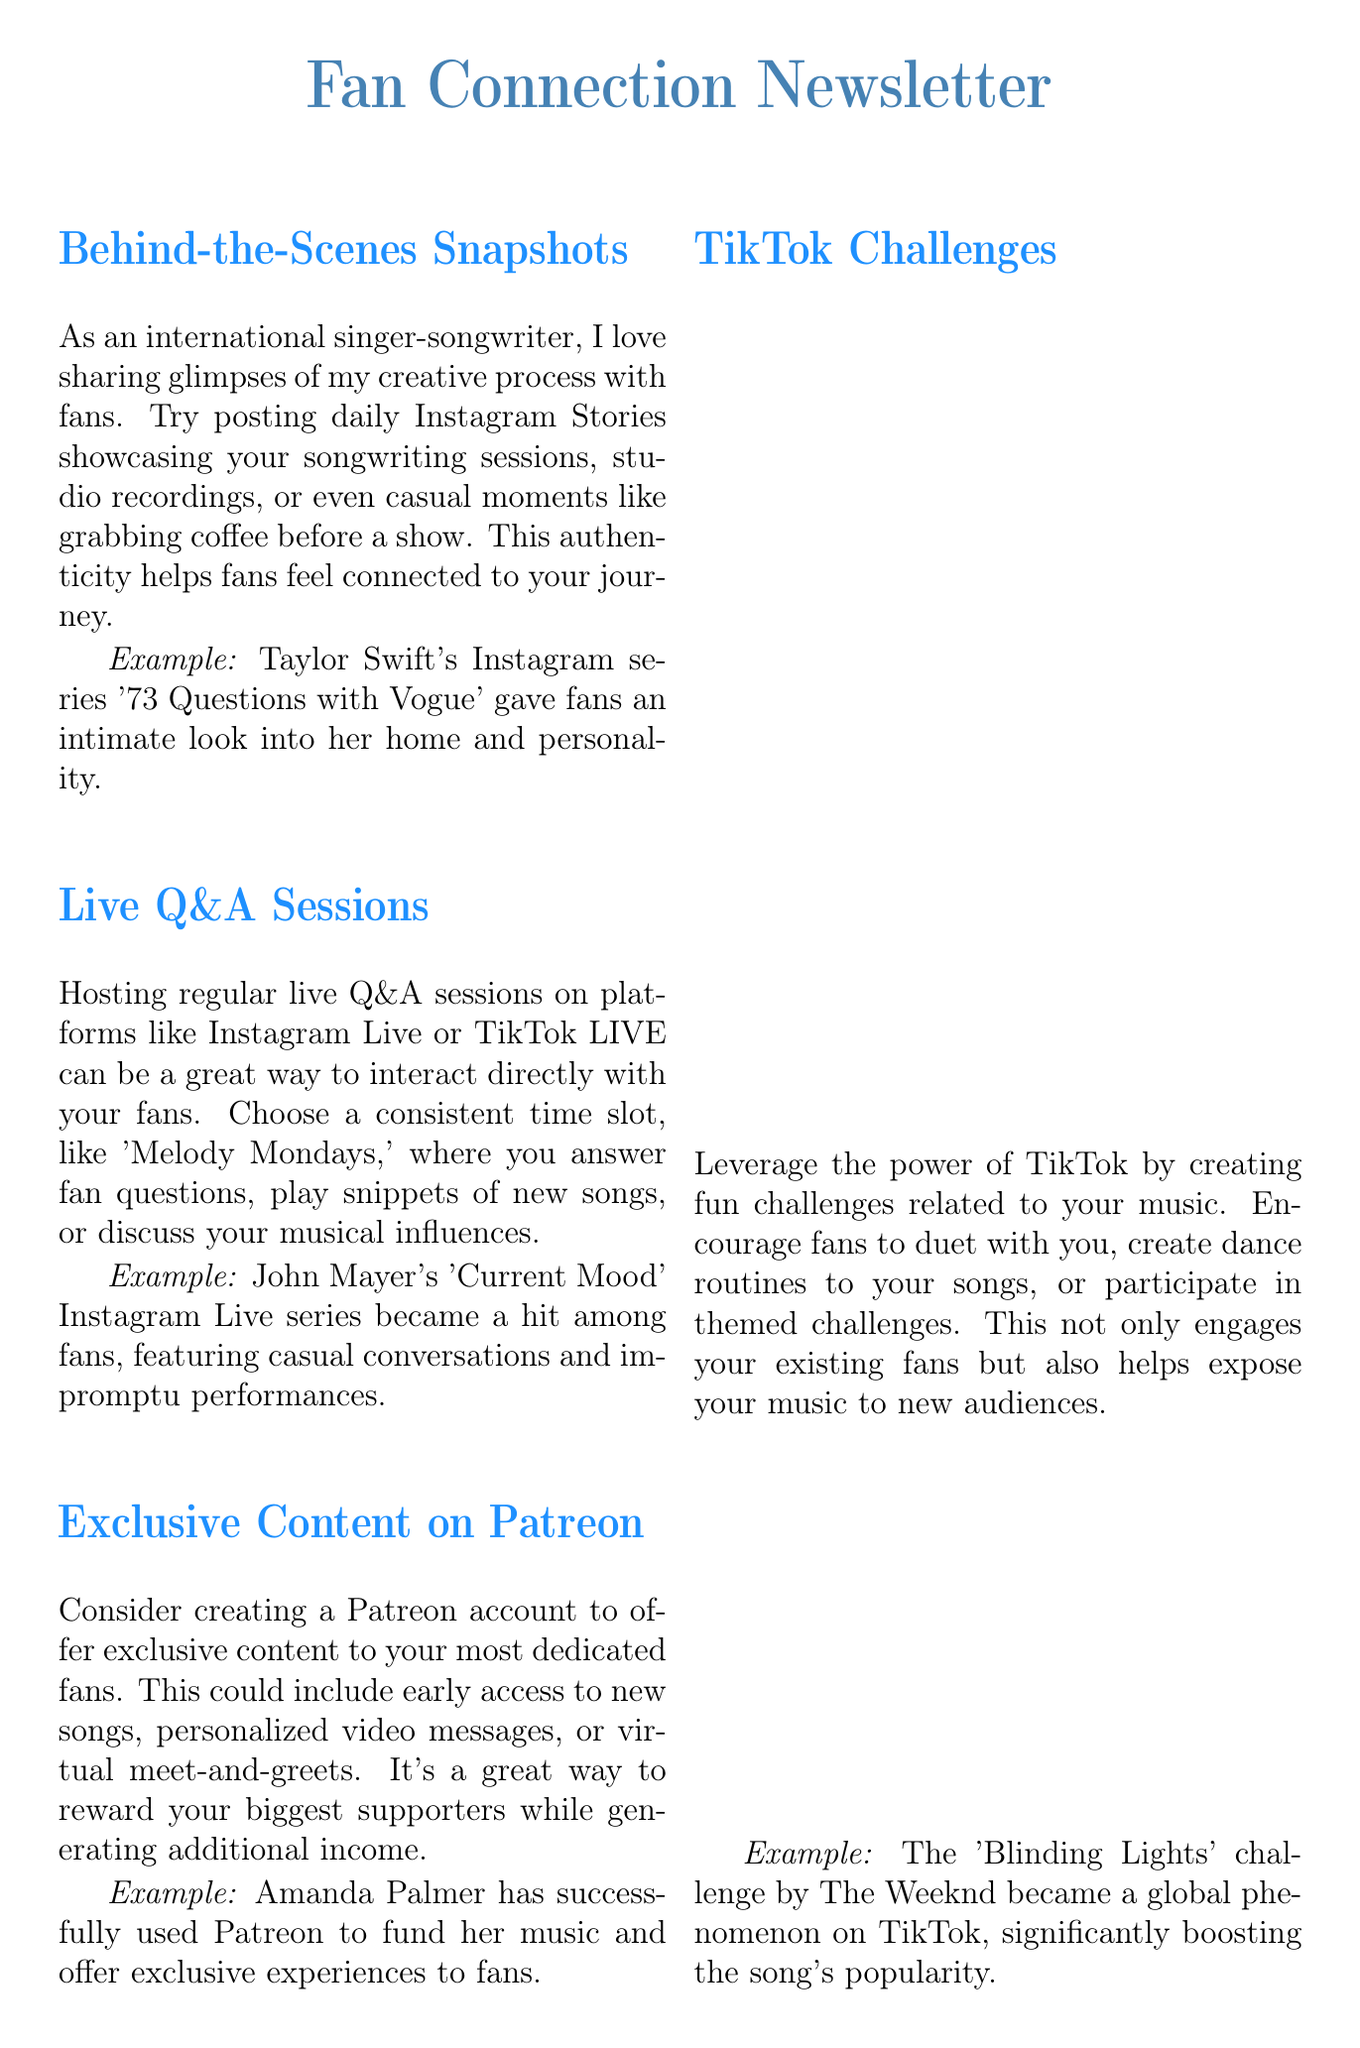What is the title of the newsletter? The title is the main heading that introduces the content of the document.
Answer: Fan Connection Newsletter Who hosted the 'Current Mood' Instagram Live series? The document provides an example of a successful live Q&A session and names the individual responsible.
Answer: John Mayer What platform is suggested for virtual concerts? The document mentions platforms suitable for virtual events in its description.
Answer: YouTube Live What day is suggested for hosting regular live Q&A sessions? The content recommends a specific theme for the day when the sessions should take place.
Answer: Melody Mondays Which artist used Patreon successfully for exclusive experiences? The document highlights a specific artist's use of Patreon for fan engagement.
Answer: Amanda Palmer What was the title of BTS's virtual concert in 2020? The document states the name of the specific concert that had a large audience.
Answer: Bang Bang Con: The Live What challenge became a global phenomenon on TikTok? The document refers to a music challenge that significantly boosted popularity on TikTok.
Answer: Blinding Lights challenge What type of content is suggested for encouraging fan engagement through art? The document mentions a form of creative content that fans can create, which boosts engagement.
Answer: Fan art Which artist is known for sharing fan art on Instagram? The document provides an example of an artist known for showcasing fan creations.
Answer: Lady Gaga 